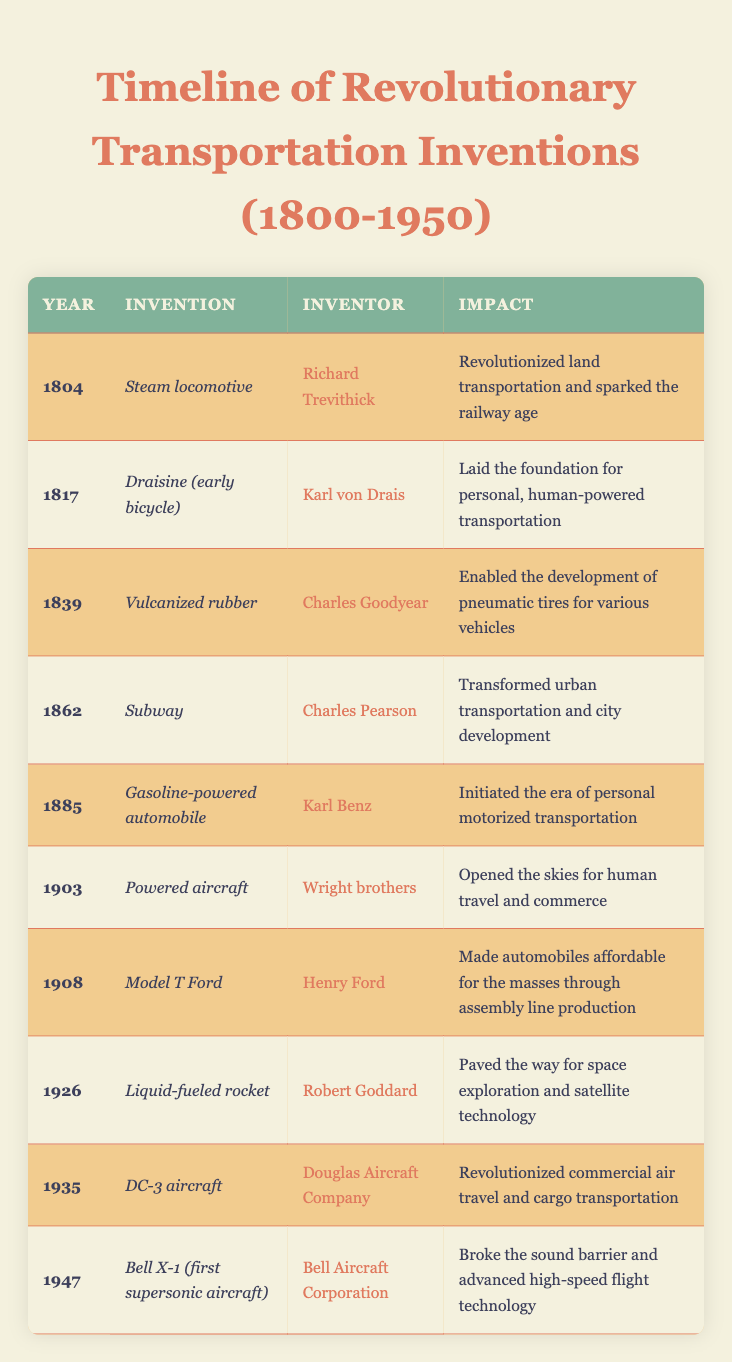What year was the steam locomotive invented? According to the table, the steam locomotive was invented in the year 1804, as shown in the corresponding row under the "Year" column.
Answer: 1804 Who invented the gasoline-powered automobile? The table indicates that Karl Benz was the inventor of the gasoline-powered automobile, listed under the "Inventor" column next to the year 1885.
Answer: Karl Benz Which invention paved the way for space exploration? The invention that paved the way for space exploration is the liquid-fueled rocket, invented by Robert Goddard in 1926, as detailed in the Impact column.
Answer: Liquid-fueled rocket What is the average year of the inventions listed in the table? The years of the inventions are 1804, 1817, 1839, 1862, 1885, 1903, 1908, 1926, 1935, and 1947. When summed up, the total is 1866. Since there are 10 inventions, the average year is 1866 divided by 10, which equals 186.6.  The average year is therefore approximately 1866.
Answer: 1866 Is the DC-3 aircraft associated with commercial air travel? Yes, the table states that the DC-3 aircraft, invented by Douglas Aircraft Company in 1935, revolutionized commercial air travel and cargo transportation, indicating a clear association.
Answer: Yes What impact did the invention of the Model T Ford have? The Model T Ford made automobiles affordable for the masses through assembly line production, as noted in the Impact column next to the year 1908 in the table.
Answer: Made automobiles affordable for the masses In which year did the Bell X-1 become the first supersonic aircraft? The table specifies that the Bell X-1, recognized as the first supersonic aircraft, was invented in 1947. This information can be found in the respective entry under the "Year" column.
Answer: 1947 Which invention came first, the subway or the gasoline-powered automobile? By comparing the years, the subway was invented in 1862 while the gasoline-powered automobile was invented in 1885. Since 1862 is earlier than 1885, the subway came first.
Answer: Subway What is the total number of inventions listed in the table? The table includes 10 entries, each representing a revolutionary transportation invention from 1800 to 1950, which can be easily counted by observing the rows.
Answer: 10 